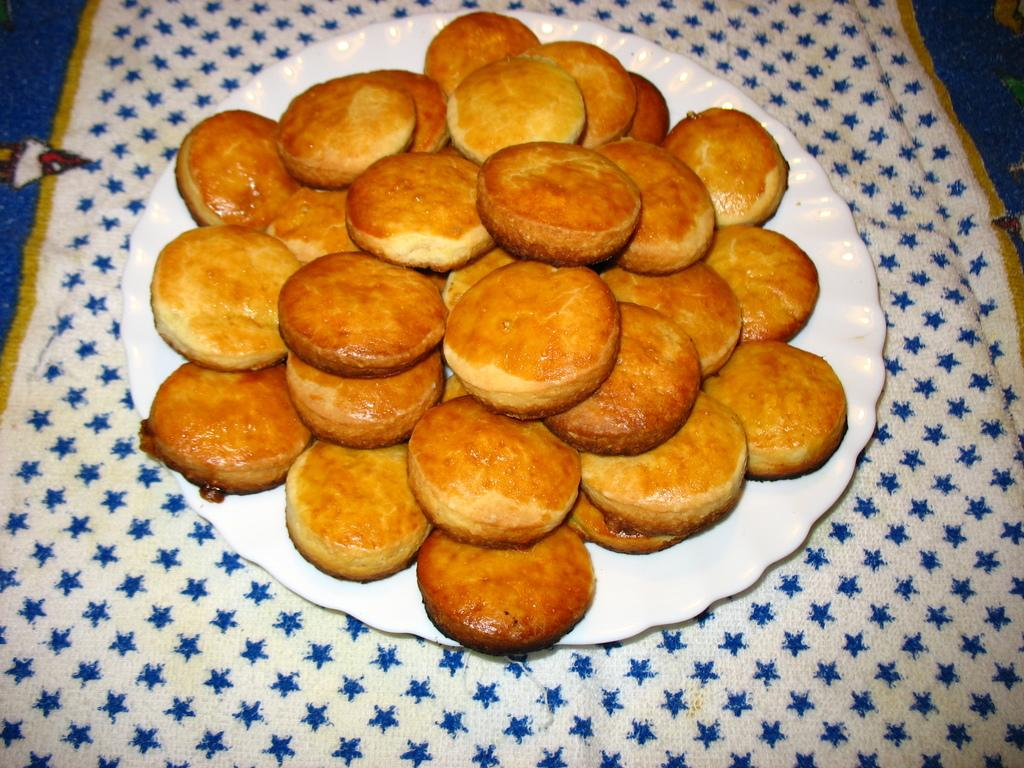What type of food is present on the plate in the image? There are many biscuits on the plate in the image. What is located beneath the plate? There is a cloth below the plate. What type of pets are visible in the image? There are no pets visible in the image. What type of fowl can be seen in the image? There is no fowl present in the image. 